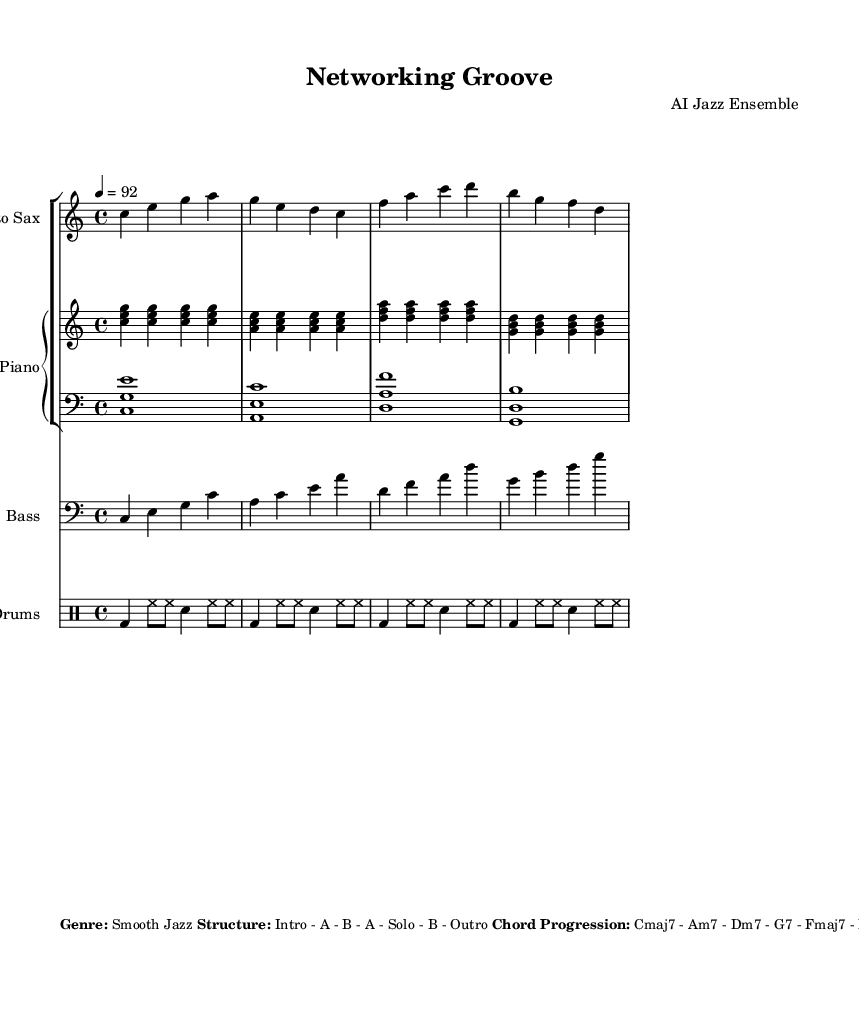What is the key signature of this music? The key signature is C major, which is indicated by the absence of sharps or flats.
Answer: C major What is the time signature of this piece? The time signature is indicated at the beginning of the score as 4/4, meaning there are four beats in each measure.
Answer: 4/4 What is the tempo marking for this piece? The tempo is indicated as quarter note equals 92, meaning each quarter note should be played at a speed of 92 beats per minute.
Answer: 92 How many measures are in the saxophone part? To find this, count the number of groups of bars in the saxophone part which consists of four measures repeated, resulting in a total of 16 measures.
Answer: 16 What is the chord progression for the piece? The chord progression is listed in the markup, indicating the sequence of chords which includes Cmaj7, Am7, Dm7, G7, Fmaj7, Em7, Dm7, G7.
Answer: Cmaj7 - Am7 - Dm7 - G7 - Fmaj7 - Em7 - Dm7 - G7 What is the structure of this composition? The structure is described as Intro - A - B - A - Solo - B - Outro, sharing how the different sections are arranged.
Answer: Intro - A - B - A - Solo - B - Outro What is the primary instrument taking the lead on melody? The markup specifies that the saxophone is the lead instrument for the melody, showcasing its prominence in the piece.
Answer: Saxophone 